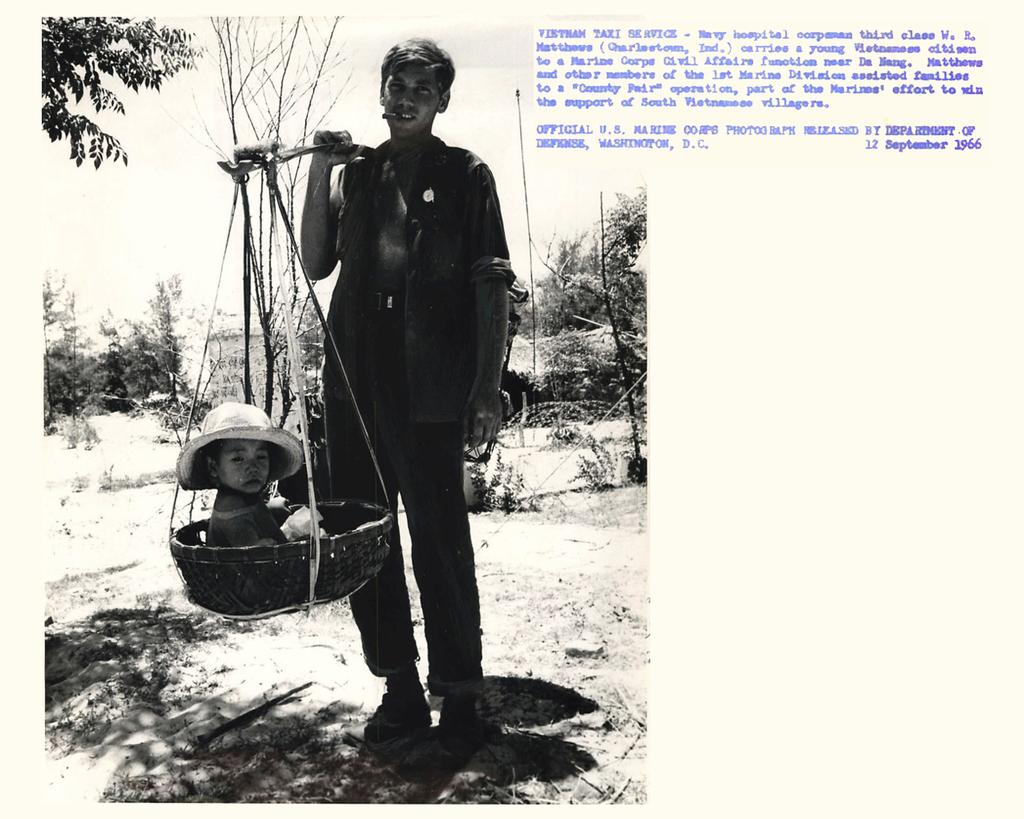What is the main subject of the image? There is a man standing in the image. What is the man doing in the image? The man is carrying a child in a basket. What can be seen in the background of the image? There are trees in the backdrop of the image. How would you describe the weather in the image? The sky is clear in the image, suggesting good weather. Where is the basketball located in the image? There is no basketball present in the image. Can you tell me how many beds are visible in the image? There are no beds visible in the image. 